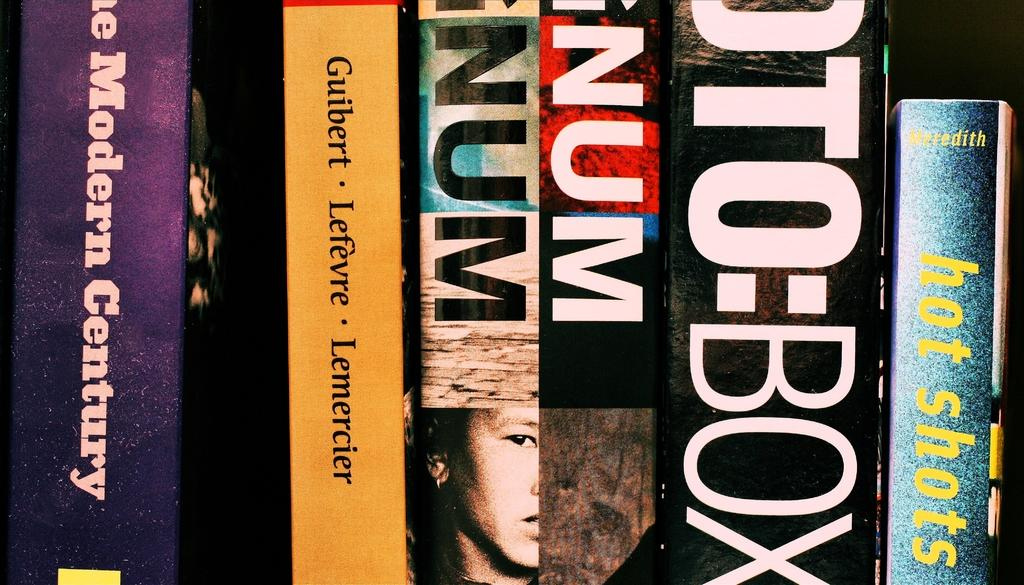<image>
Render a clear and concise summary of the photo. Hot Shots is the title on one Partial book bind in a row of many. 